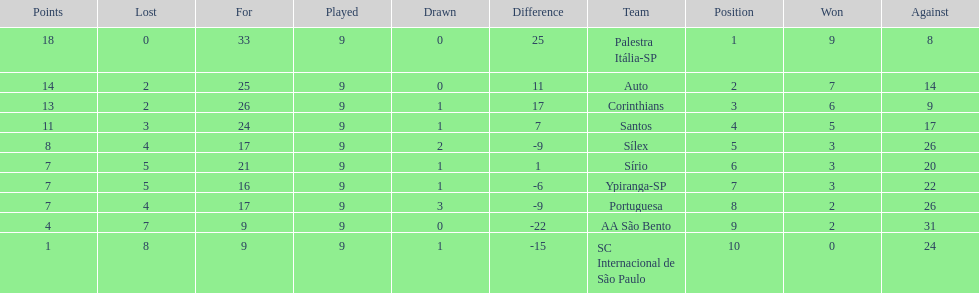Which brazilian team took the top spot in the 1926 brazilian football cup? Palestra Itália-SP. 